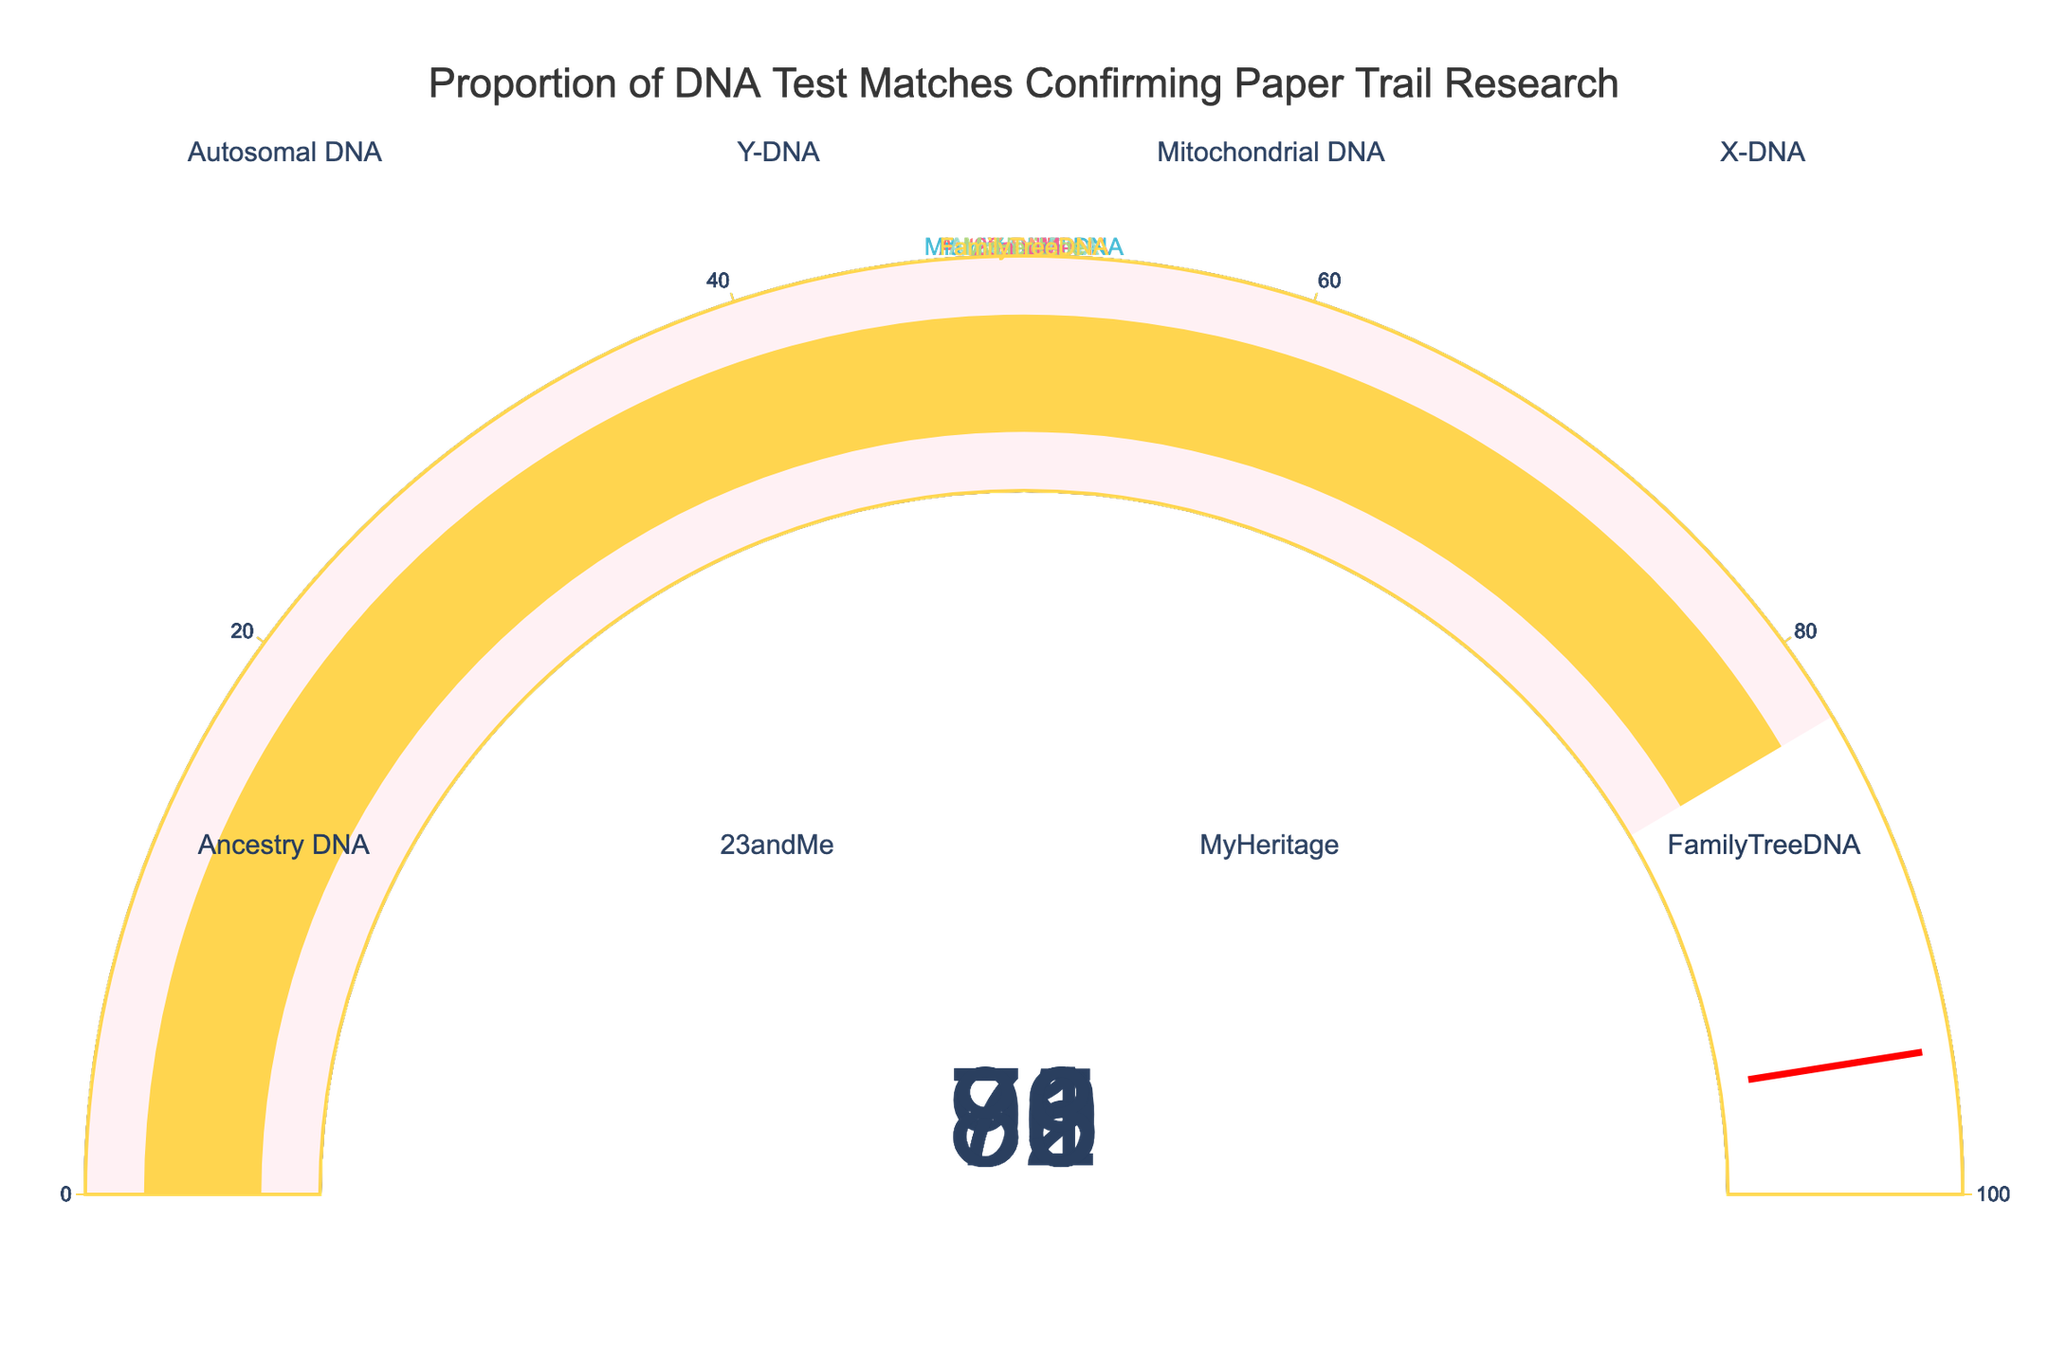Which DNA test type has the highest percentage of matches confirming the paper trail research? The gauge chart shows that Y-DNA has the highest percentage at 92%.
Answer: Y-DNA Which DNA test type has the lowest percentage of matches confirming the paper trail research? The gauge chart indicates that X-DNA has the lowest percentage at 73%.
Answer: X-DNA What is the average percentage of matches confirming the paper trail research across all DNA test types? Add all the percentages (78 + 92 + 85 + 73 + 81 + 76 + 79 + 83) and divide by the number of test types (8). The total sum is 647, so the average is 647 / 8 = 80.875.
Answer: 80.875 How many DNA test types have a percentage of matches above 80%? From the gauge chart, the test types with percentages above 80% are Y-DNA (92%), Mitochondrial DNA (85%), Ancestry DNA (81%), and FamilyTreeDNA (83%). There are 4 test types in total.
Answer: 4 What is the difference in the percentage of matches between the test type with the highest and the lowest percentages? The test type with the highest percentage is Y-DNA (92%), and the one with the lowest is X-DNA (73%). The difference is 92 - 73 = 19.
Answer: 19 Which test type has a percentage of matches closest to the average percentage of all test types? The average percentage is 80.875. Comparing this to individual percentages, the closest is FamilyTreeDNA (83%).
Answer: FamilyTreeDNA Do more DNA test types have match percentages above or below the average percentage? The average percentage is 80.875. Test types above the average: Y-DNA (92%), Mitochondrial DNA (85%), Ancestry DNA (81%), FamilyTreeDNA (83%). Test types below the average: Autosomal DNA (78%), X-DNA (73%), 23andMe (76%), MyHeritage (79%). Both have 4 test types.
Answer: Equal number above and below What is the median percentage of matches confirming the paper trail research? The sorted percentages are 73, 76, 78, 79, 81, 83, 85, 92. The median is the average of the 4th and 5th values: (79 + 81) / 2 = 80.
Answer: 80 Which percentages exceed the threshold value indicated on the gauges (95%)? None of the percentages in the gauge chart exceed the threshold value of 95%.
Answer: None 